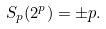<formula> <loc_0><loc_0><loc_500><loc_500>S _ { p } ( 2 ^ { p } ) = \pm p .</formula> 